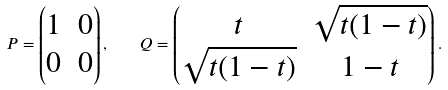Convert formula to latex. <formula><loc_0><loc_0><loc_500><loc_500>P = \begin{pmatrix} 1 & 0 \\ 0 & 0 \end{pmatrix} , \quad Q = \begin{pmatrix} t & \sqrt { t ( 1 - t ) } \\ \sqrt { t ( 1 - t ) } & 1 - t \end{pmatrix} .</formula> 